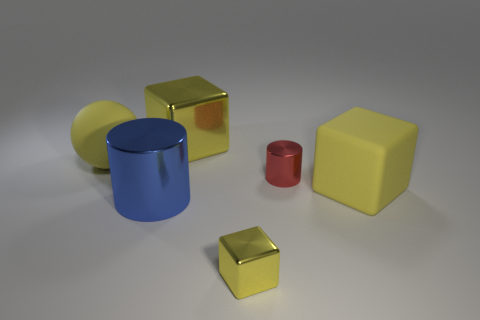Add 4 large rubber spheres. How many objects exist? 10 Subtract all large yellow blocks. How many blocks are left? 1 Subtract all blue cylinders. How many cylinders are left? 1 Subtract 1 cylinders. How many cylinders are left? 1 Subtract all green cylinders. Subtract all gray blocks. How many cylinders are left? 2 Subtract all blue cylinders. How many blue blocks are left? 0 Subtract all purple balls. Subtract all large balls. How many objects are left? 5 Add 6 shiny blocks. How many shiny blocks are left? 8 Add 3 big yellow matte blocks. How many big yellow matte blocks exist? 4 Subtract 0 cyan cylinders. How many objects are left? 6 